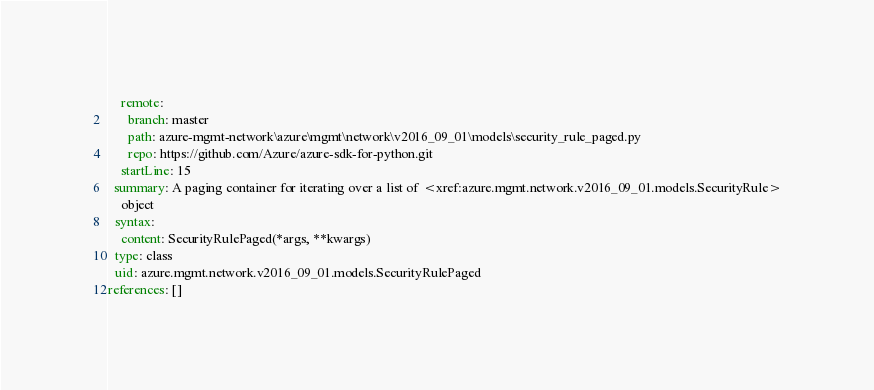Convert code to text. <code><loc_0><loc_0><loc_500><loc_500><_YAML_>    remote:
      branch: master
      path: azure-mgmt-network\azure\mgmt\network\v2016_09_01\models\security_rule_paged.py
      repo: https://github.com/Azure/azure-sdk-for-python.git
    startLine: 15
  summary: A paging container for iterating over a list of <xref:azure.mgmt.network.v2016_09_01.models.SecurityRule>
    object
  syntax:
    content: SecurityRulePaged(*args, **kwargs)
  type: class
  uid: azure.mgmt.network.v2016_09_01.models.SecurityRulePaged
references: []
</code> 